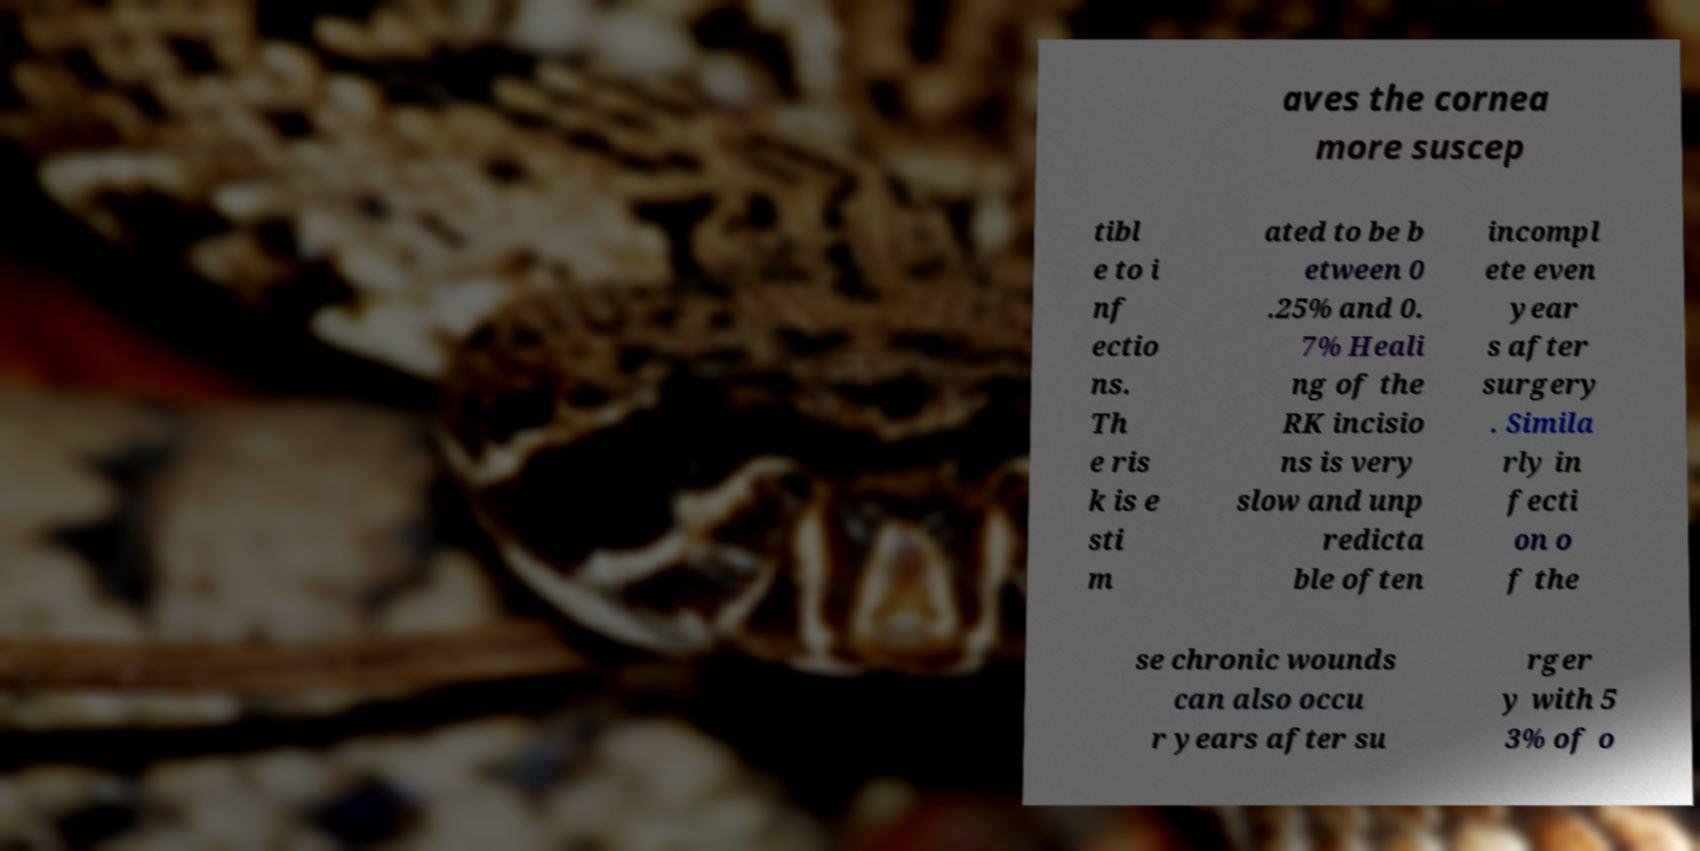Can you accurately transcribe the text from the provided image for me? aves the cornea more suscep tibl e to i nf ectio ns. Th e ris k is e sti m ated to be b etween 0 .25% and 0. 7% Heali ng of the RK incisio ns is very slow and unp redicta ble often incompl ete even year s after surgery . Simila rly in fecti on o f the se chronic wounds can also occu r years after su rger y with 5 3% of o 